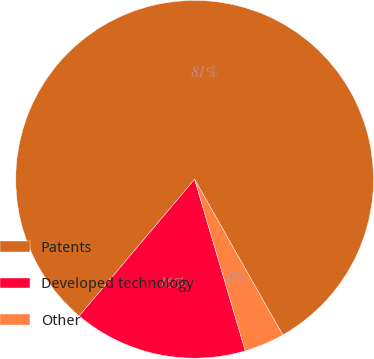Convert chart. <chart><loc_0><loc_0><loc_500><loc_500><pie_chart><fcel>Patents<fcel>Developed technology<fcel>Other<nl><fcel>80.64%<fcel>15.73%<fcel>3.63%<nl></chart> 